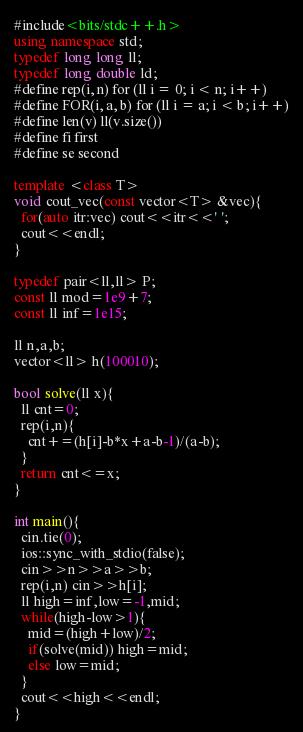Convert code to text. <code><loc_0><loc_0><loc_500><loc_500><_C++_>#include<bits/stdc++.h>
using namespace std;
typedef long long ll;
typedef long double ld;
#define rep(i, n) for (ll i = 0; i < n; i++)
#define FOR(i, a, b) for (ll i = a; i < b; i++)
#define len(v) ll(v.size())
#define fi first
#define se second

template <class T>
void cout_vec(const vector<T> &vec){
  for(auto itr:vec) cout<<itr<<' ';
  cout<<endl;
}

typedef pair<ll,ll> P;
const ll mod=1e9+7;
const ll inf=1e15;

ll n,a,b;
vector<ll> h(100010);

bool solve(ll x){
  ll cnt=0;
  rep(i,n){
    cnt+=(h[i]-b*x+a-b-1)/(a-b);
  }
  return cnt<=x;
}

int main(){
  cin.tie(0);
  ios::sync_with_stdio(false);
  cin>>n>>a>>b;
  rep(i,n) cin>>h[i];
  ll high=inf,low=-1,mid;
  while(high-low>1){
    mid=(high+low)/2;
    if(solve(mid)) high=mid;
    else low=mid;
  }
  cout<<high<<endl;
}</code> 